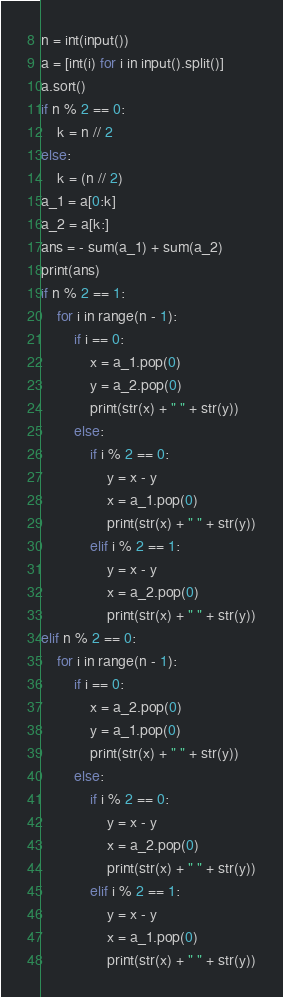Convert code to text. <code><loc_0><loc_0><loc_500><loc_500><_Python_>n = int(input())
a = [int(i) for i in input().split()]
a.sort()
if n % 2 == 0:
    k = n // 2
else:
    k = (n // 2)
a_1 = a[0:k]
a_2 = a[k:]
ans = - sum(a_1) + sum(a_2)
print(ans)
if n % 2 == 1:
    for i in range(n - 1):
        if i == 0:
            x = a_1.pop(0)            
            y = a_2.pop(0)
            print(str(x) + " " + str(y))
        else:
            if i % 2 == 0:
                y = x - y
                x = a_1.pop(0)
                print(str(x) + " " + str(y))
            elif i % 2 == 1:
                y = x - y
                x = a_2.pop(0)
                print(str(x) + " " + str(y))
elif n % 2 == 0:
    for i in range(n - 1):
        if i == 0:
            x = a_2.pop(0)
            y = a_1.pop(0)
            print(str(x) + " " + str(y))
        else:
            if i % 2 == 0:
                y = x - y
                x = a_2.pop(0)
                print(str(x) + " " + str(y))
            elif i % 2 == 1:
                y = x - y
                x = a_1.pop(0)
                print(str(x) + " " + str(y))</code> 